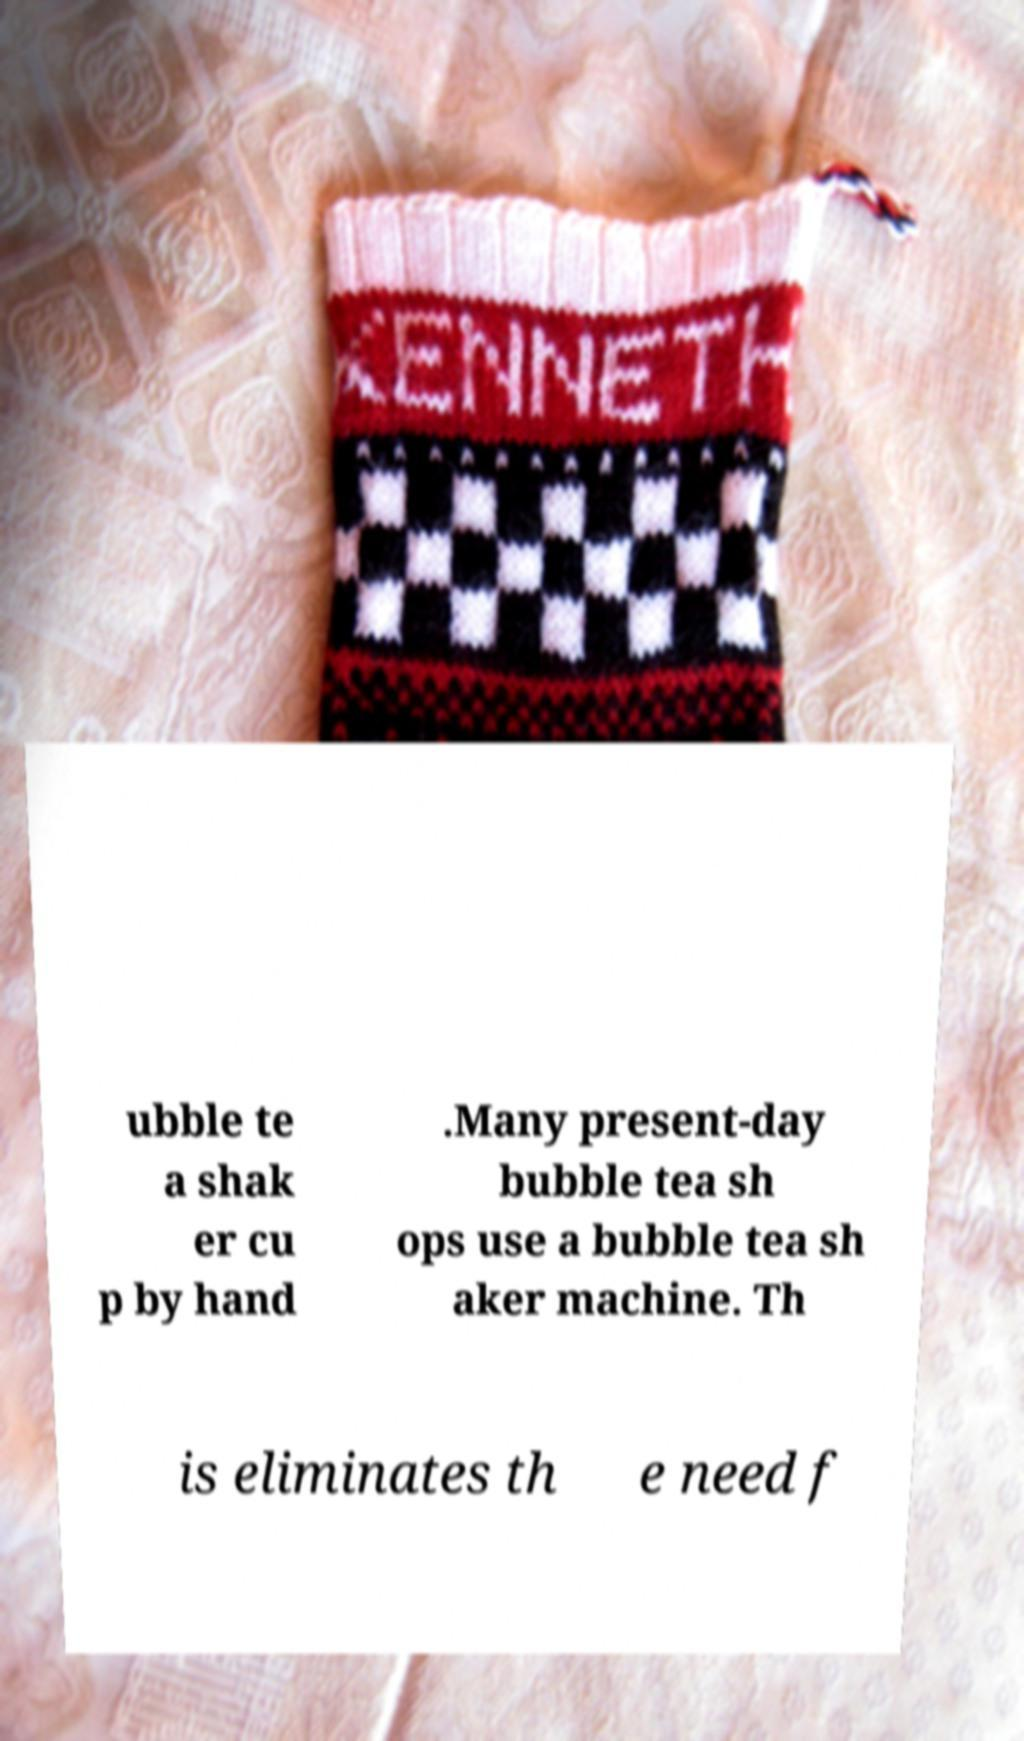Please read and relay the text visible in this image. What does it say? ubble te a shak er cu p by hand .Many present-day bubble tea sh ops use a bubble tea sh aker machine. Th is eliminates th e need f 